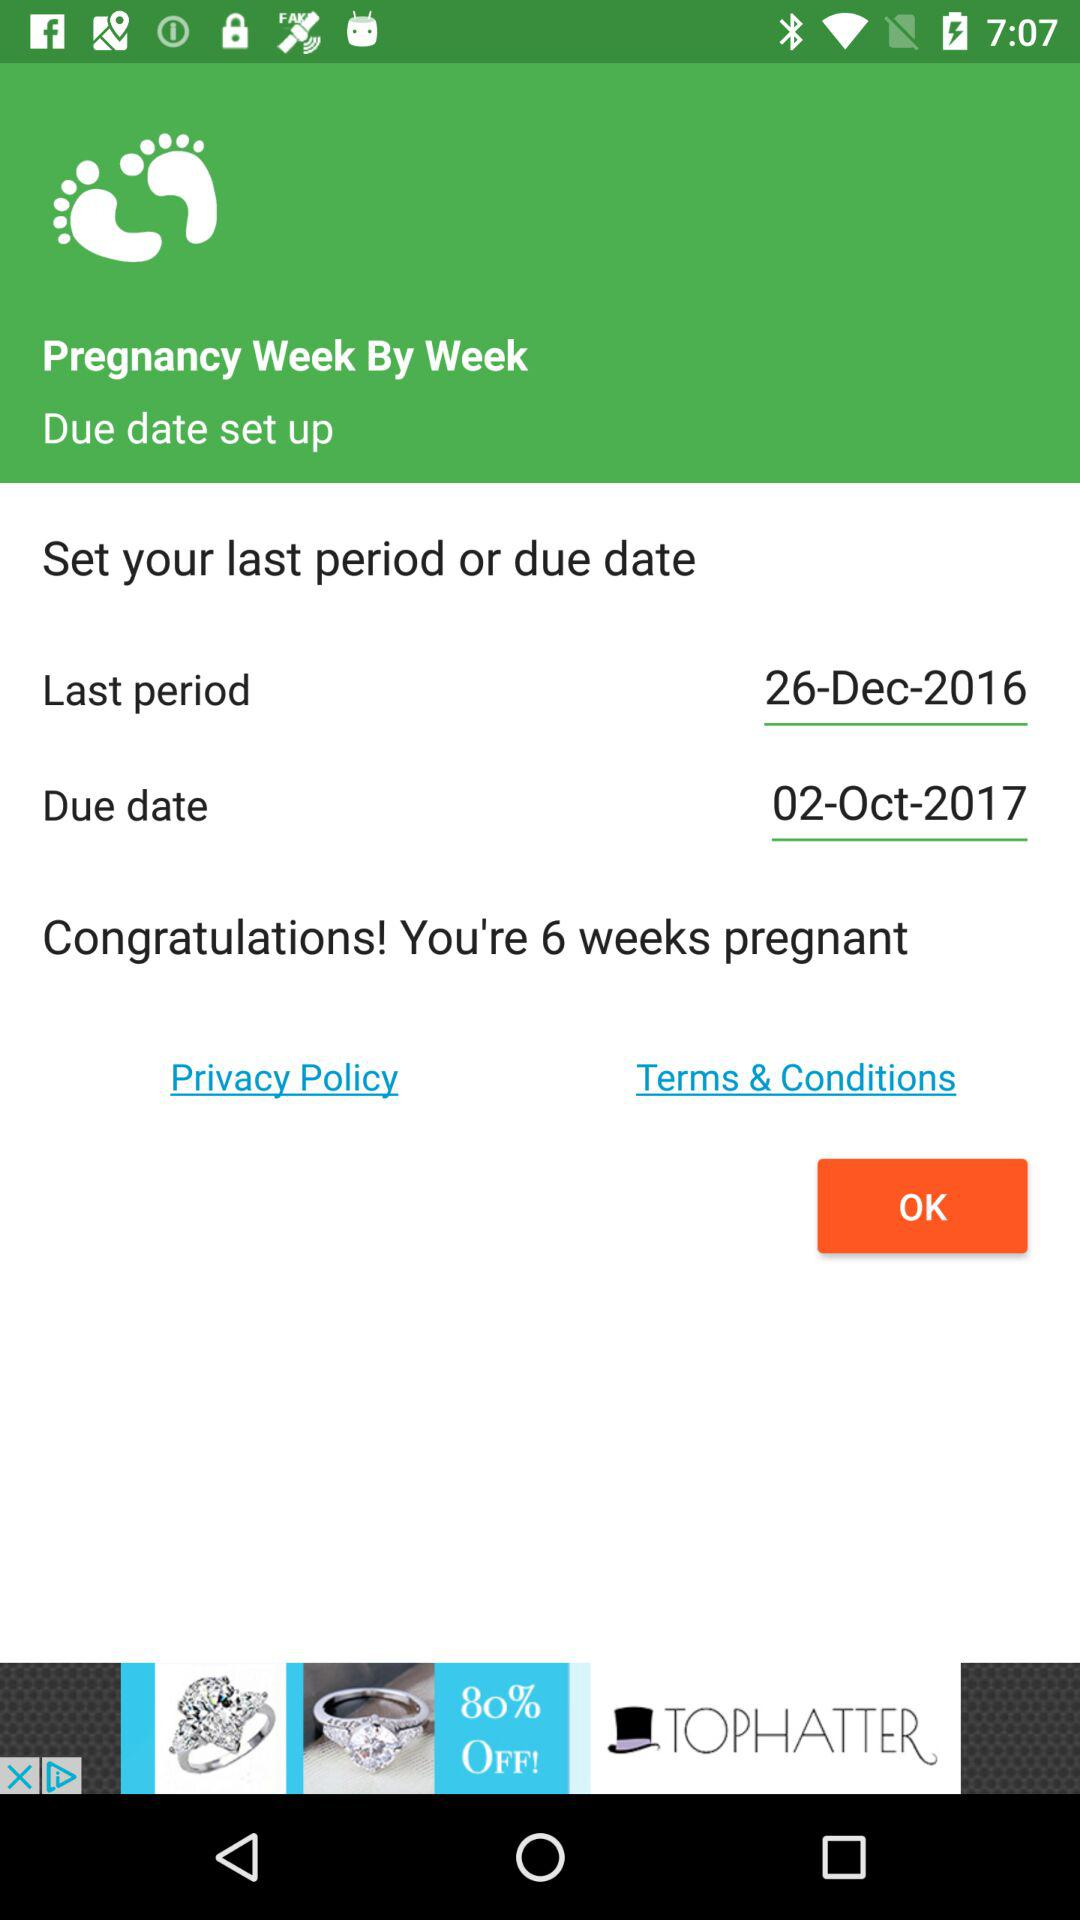How many weeks have you been pregnant? You have been pregnant for 6 weeks. 